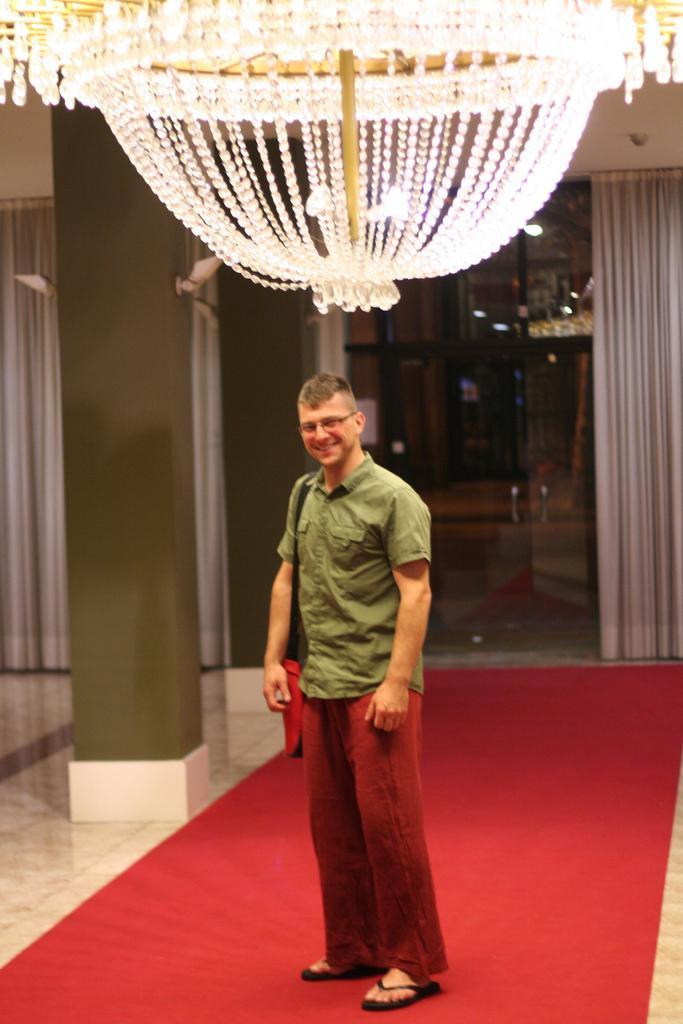How would you summarize this image in a sentence or two? In this picture there is a man standing and smiling. At the back there is a door and there are curtains and there is a pillar. At the top there is a chandelier. At the bottom there is a floor and there is a carpet. 